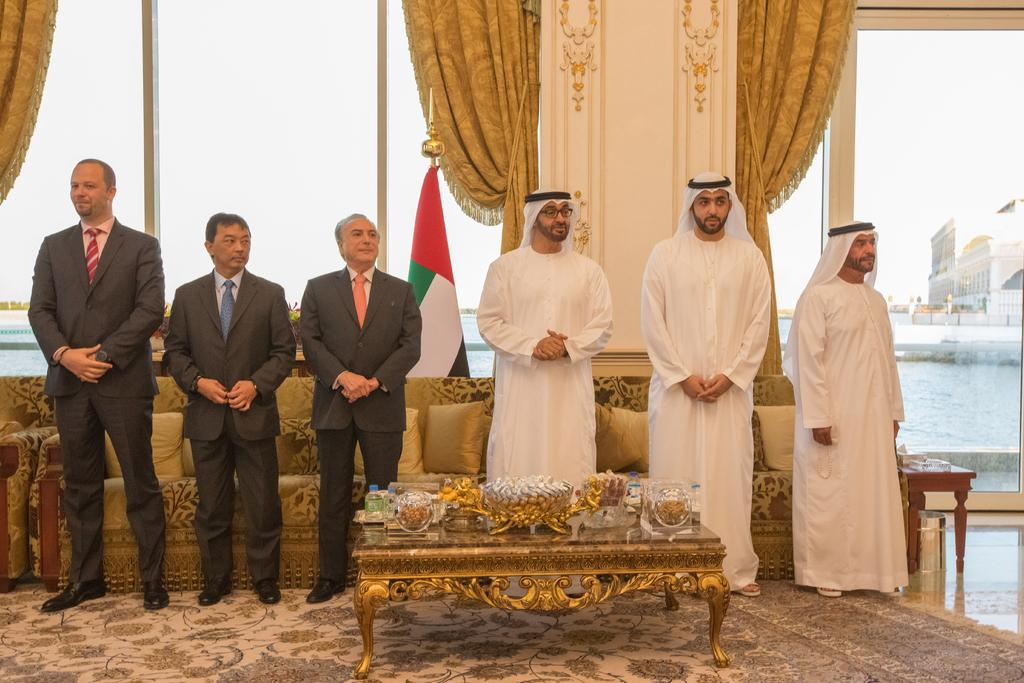How many people are visible in the image? There are people standing in the image. What surface are the people standing on? The people are standing on the floor. What furniture can be seen in the image? There is a table in the image. What is on the table? There is a bowl on the table, and food items are present in the bowl. What beverages are visible on the table? There is a water bottle and a wine bottle on the table. What type of kite is being flown in the lunchroom? There is no kite present in the image, and the setting does not appear to be a lunchroom. 